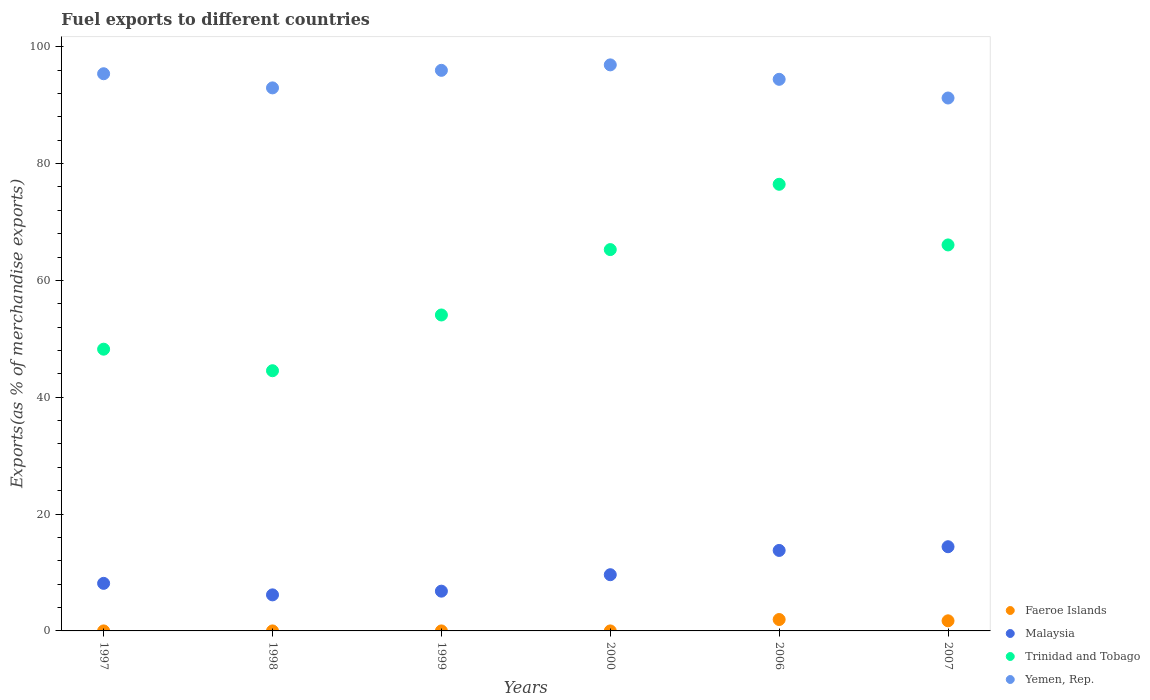What is the percentage of exports to different countries in Trinidad and Tobago in 1999?
Offer a terse response. 54.08. Across all years, what is the maximum percentage of exports to different countries in Trinidad and Tobago?
Your response must be concise. 76.46. Across all years, what is the minimum percentage of exports to different countries in Yemen, Rep.?
Provide a short and direct response. 91.23. What is the total percentage of exports to different countries in Malaysia in the graph?
Your answer should be compact. 58.93. What is the difference between the percentage of exports to different countries in Malaysia in 1997 and that in 1999?
Offer a terse response. 1.34. What is the difference between the percentage of exports to different countries in Faeroe Islands in 2006 and the percentage of exports to different countries in Yemen, Rep. in 2007?
Your response must be concise. -89.28. What is the average percentage of exports to different countries in Yemen, Rep. per year?
Offer a terse response. 94.48. In the year 1998, what is the difference between the percentage of exports to different countries in Faeroe Islands and percentage of exports to different countries in Yemen, Rep.?
Your response must be concise. -92.96. What is the ratio of the percentage of exports to different countries in Faeroe Islands in 1998 to that in 2006?
Keep it short and to the point. 0. What is the difference between the highest and the second highest percentage of exports to different countries in Yemen, Rep.?
Offer a very short reply. 0.93. What is the difference between the highest and the lowest percentage of exports to different countries in Yemen, Rep.?
Provide a short and direct response. 5.67. Is the sum of the percentage of exports to different countries in Faeroe Islands in 2000 and 2006 greater than the maximum percentage of exports to different countries in Trinidad and Tobago across all years?
Your answer should be compact. No. Does the percentage of exports to different countries in Faeroe Islands monotonically increase over the years?
Your response must be concise. No. Is the percentage of exports to different countries in Faeroe Islands strictly less than the percentage of exports to different countries in Yemen, Rep. over the years?
Your answer should be compact. Yes. How many dotlines are there?
Your response must be concise. 4. What is the difference between two consecutive major ticks on the Y-axis?
Offer a terse response. 20. Are the values on the major ticks of Y-axis written in scientific E-notation?
Keep it short and to the point. No. Does the graph contain any zero values?
Keep it short and to the point. No. Does the graph contain grids?
Provide a succinct answer. No. Where does the legend appear in the graph?
Provide a succinct answer. Bottom right. How many legend labels are there?
Your answer should be very brief. 4. What is the title of the graph?
Offer a terse response. Fuel exports to different countries. Does "Sudan" appear as one of the legend labels in the graph?
Your answer should be compact. No. What is the label or title of the Y-axis?
Keep it short and to the point. Exports(as % of merchandise exports). What is the Exports(as % of merchandise exports) in Faeroe Islands in 1997?
Ensure brevity in your answer.  0. What is the Exports(as % of merchandise exports) in Malaysia in 1997?
Give a very brief answer. 8.14. What is the Exports(as % of merchandise exports) of Trinidad and Tobago in 1997?
Provide a short and direct response. 48.23. What is the Exports(as % of merchandise exports) in Yemen, Rep. in 1997?
Offer a very short reply. 95.38. What is the Exports(as % of merchandise exports) of Faeroe Islands in 1998?
Your answer should be compact. 0. What is the Exports(as % of merchandise exports) of Malaysia in 1998?
Offer a very short reply. 6.17. What is the Exports(as % of merchandise exports) of Trinidad and Tobago in 1998?
Your answer should be very brief. 44.54. What is the Exports(as % of merchandise exports) of Yemen, Rep. in 1998?
Your answer should be very brief. 92.96. What is the Exports(as % of merchandise exports) of Faeroe Islands in 1999?
Make the answer very short. 0. What is the Exports(as % of merchandise exports) of Malaysia in 1999?
Make the answer very short. 6.81. What is the Exports(as % of merchandise exports) in Trinidad and Tobago in 1999?
Make the answer very short. 54.08. What is the Exports(as % of merchandise exports) in Yemen, Rep. in 1999?
Give a very brief answer. 95.96. What is the Exports(as % of merchandise exports) in Faeroe Islands in 2000?
Your response must be concise. 5.55871303274651e-5. What is the Exports(as % of merchandise exports) in Malaysia in 2000?
Your answer should be very brief. 9.62. What is the Exports(as % of merchandise exports) in Trinidad and Tobago in 2000?
Your answer should be very brief. 65.28. What is the Exports(as % of merchandise exports) of Yemen, Rep. in 2000?
Provide a short and direct response. 96.9. What is the Exports(as % of merchandise exports) of Faeroe Islands in 2006?
Provide a succinct answer. 1.95. What is the Exports(as % of merchandise exports) in Malaysia in 2006?
Your answer should be very brief. 13.78. What is the Exports(as % of merchandise exports) in Trinidad and Tobago in 2006?
Provide a short and direct response. 76.46. What is the Exports(as % of merchandise exports) in Yemen, Rep. in 2006?
Make the answer very short. 94.43. What is the Exports(as % of merchandise exports) of Faeroe Islands in 2007?
Give a very brief answer. 1.73. What is the Exports(as % of merchandise exports) of Malaysia in 2007?
Provide a short and direct response. 14.41. What is the Exports(as % of merchandise exports) in Trinidad and Tobago in 2007?
Give a very brief answer. 66.08. What is the Exports(as % of merchandise exports) in Yemen, Rep. in 2007?
Your answer should be compact. 91.23. Across all years, what is the maximum Exports(as % of merchandise exports) of Faeroe Islands?
Your answer should be very brief. 1.95. Across all years, what is the maximum Exports(as % of merchandise exports) in Malaysia?
Offer a terse response. 14.41. Across all years, what is the maximum Exports(as % of merchandise exports) of Trinidad and Tobago?
Your response must be concise. 76.46. Across all years, what is the maximum Exports(as % of merchandise exports) of Yemen, Rep.?
Offer a very short reply. 96.9. Across all years, what is the minimum Exports(as % of merchandise exports) in Faeroe Islands?
Give a very brief answer. 5.55871303274651e-5. Across all years, what is the minimum Exports(as % of merchandise exports) in Malaysia?
Keep it short and to the point. 6.17. Across all years, what is the minimum Exports(as % of merchandise exports) of Trinidad and Tobago?
Offer a very short reply. 44.54. Across all years, what is the minimum Exports(as % of merchandise exports) of Yemen, Rep.?
Provide a short and direct response. 91.23. What is the total Exports(as % of merchandise exports) of Faeroe Islands in the graph?
Make the answer very short. 3.68. What is the total Exports(as % of merchandise exports) of Malaysia in the graph?
Your answer should be compact. 58.93. What is the total Exports(as % of merchandise exports) of Trinidad and Tobago in the graph?
Your response must be concise. 354.66. What is the total Exports(as % of merchandise exports) in Yemen, Rep. in the graph?
Your answer should be very brief. 566.85. What is the difference between the Exports(as % of merchandise exports) of Faeroe Islands in 1997 and that in 1998?
Your answer should be compact. 0. What is the difference between the Exports(as % of merchandise exports) in Malaysia in 1997 and that in 1998?
Offer a terse response. 1.97. What is the difference between the Exports(as % of merchandise exports) in Trinidad and Tobago in 1997 and that in 1998?
Give a very brief answer. 3.69. What is the difference between the Exports(as % of merchandise exports) in Yemen, Rep. in 1997 and that in 1998?
Your answer should be very brief. 2.42. What is the difference between the Exports(as % of merchandise exports) in Faeroe Islands in 1997 and that in 1999?
Offer a very short reply. 0. What is the difference between the Exports(as % of merchandise exports) of Malaysia in 1997 and that in 1999?
Provide a short and direct response. 1.34. What is the difference between the Exports(as % of merchandise exports) of Trinidad and Tobago in 1997 and that in 1999?
Offer a terse response. -5.86. What is the difference between the Exports(as % of merchandise exports) in Yemen, Rep. in 1997 and that in 1999?
Keep it short and to the point. -0.58. What is the difference between the Exports(as % of merchandise exports) of Malaysia in 1997 and that in 2000?
Make the answer very short. -1.48. What is the difference between the Exports(as % of merchandise exports) of Trinidad and Tobago in 1997 and that in 2000?
Your answer should be compact. -17.05. What is the difference between the Exports(as % of merchandise exports) in Yemen, Rep. in 1997 and that in 2000?
Give a very brief answer. -1.52. What is the difference between the Exports(as % of merchandise exports) of Faeroe Islands in 1997 and that in 2006?
Ensure brevity in your answer.  -1.95. What is the difference between the Exports(as % of merchandise exports) of Malaysia in 1997 and that in 2006?
Make the answer very short. -5.64. What is the difference between the Exports(as % of merchandise exports) of Trinidad and Tobago in 1997 and that in 2006?
Provide a short and direct response. -28.23. What is the difference between the Exports(as % of merchandise exports) of Yemen, Rep. in 1997 and that in 2006?
Keep it short and to the point. 0.95. What is the difference between the Exports(as % of merchandise exports) of Faeroe Islands in 1997 and that in 2007?
Ensure brevity in your answer.  -1.73. What is the difference between the Exports(as % of merchandise exports) of Malaysia in 1997 and that in 2007?
Your answer should be compact. -6.27. What is the difference between the Exports(as % of merchandise exports) of Trinidad and Tobago in 1997 and that in 2007?
Your answer should be compact. -17.85. What is the difference between the Exports(as % of merchandise exports) of Yemen, Rep. in 1997 and that in 2007?
Your response must be concise. 4.15. What is the difference between the Exports(as % of merchandise exports) in Faeroe Islands in 1998 and that in 1999?
Give a very brief answer. -0. What is the difference between the Exports(as % of merchandise exports) in Malaysia in 1998 and that in 1999?
Your answer should be compact. -0.63. What is the difference between the Exports(as % of merchandise exports) in Trinidad and Tobago in 1998 and that in 1999?
Provide a succinct answer. -9.54. What is the difference between the Exports(as % of merchandise exports) of Yemen, Rep. in 1998 and that in 1999?
Your answer should be compact. -3. What is the difference between the Exports(as % of merchandise exports) in Faeroe Islands in 1998 and that in 2000?
Provide a short and direct response. 0. What is the difference between the Exports(as % of merchandise exports) in Malaysia in 1998 and that in 2000?
Your answer should be very brief. -3.45. What is the difference between the Exports(as % of merchandise exports) in Trinidad and Tobago in 1998 and that in 2000?
Make the answer very short. -20.74. What is the difference between the Exports(as % of merchandise exports) of Yemen, Rep. in 1998 and that in 2000?
Your response must be concise. -3.94. What is the difference between the Exports(as % of merchandise exports) of Faeroe Islands in 1998 and that in 2006?
Ensure brevity in your answer.  -1.95. What is the difference between the Exports(as % of merchandise exports) in Malaysia in 1998 and that in 2006?
Offer a very short reply. -7.61. What is the difference between the Exports(as % of merchandise exports) of Trinidad and Tobago in 1998 and that in 2006?
Keep it short and to the point. -31.91. What is the difference between the Exports(as % of merchandise exports) in Yemen, Rep. in 1998 and that in 2006?
Your answer should be compact. -1.47. What is the difference between the Exports(as % of merchandise exports) in Faeroe Islands in 1998 and that in 2007?
Make the answer very short. -1.73. What is the difference between the Exports(as % of merchandise exports) of Malaysia in 1998 and that in 2007?
Provide a short and direct response. -8.24. What is the difference between the Exports(as % of merchandise exports) of Trinidad and Tobago in 1998 and that in 2007?
Your response must be concise. -21.53. What is the difference between the Exports(as % of merchandise exports) of Yemen, Rep. in 1998 and that in 2007?
Offer a terse response. 1.73. What is the difference between the Exports(as % of merchandise exports) in Faeroe Islands in 1999 and that in 2000?
Your answer should be compact. 0. What is the difference between the Exports(as % of merchandise exports) in Malaysia in 1999 and that in 2000?
Offer a very short reply. -2.82. What is the difference between the Exports(as % of merchandise exports) of Trinidad and Tobago in 1999 and that in 2000?
Make the answer very short. -11.19. What is the difference between the Exports(as % of merchandise exports) in Yemen, Rep. in 1999 and that in 2000?
Make the answer very short. -0.93. What is the difference between the Exports(as % of merchandise exports) in Faeroe Islands in 1999 and that in 2006?
Make the answer very short. -1.95. What is the difference between the Exports(as % of merchandise exports) in Malaysia in 1999 and that in 2006?
Ensure brevity in your answer.  -6.97. What is the difference between the Exports(as % of merchandise exports) in Trinidad and Tobago in 1999 and that in 2006?
Give a very brief answer. -22.37. What is the difference between the Exports(as % of merchandise exports) of Yemen, Rep. in 1999 and that in 2006?
Keep it short and to the point. 1.54. What is the difference between the Exports(as % of merchandise exports) in Faeroe Islands in 1999 and that in 2007?
Offer a terse response. -1.73. What is the difference between the Exports(as % of merchandise exports) of Malaysia in 1999 and that in 2007?
Make the answer very short. -7.61. What is the difference between the Exports(as % of merchandise exports) in Trinidad and Tobago in 1999 and that in 2007?
Offer a terse response. -11.99. What is the difference between the Exports(as % of merchandise exports) in Yemen, Rep. in 1999 and that in 2007?
Provide a short and direct response. 4.74. What is the difference between the Exports(as % of merchandise exports) of Faeroe Islands in 2000 and that in 2006?
Your answer should be compact. -1.95. What is the difference between the Exports(as % of merchandise exports) of Malaysia in 2000 and that in 2006?
Make the answer very short. -4.15. What is the difference between the Exports(as % of merchandise exports) in Trinidad and Tobago in 2000 and that in 2006?
Make the answer very short. -11.18. What is the difference between the Exports(as % of merchandise exports) of Yemen, Rep. in 2000 and that in 2006?
Ensure brevity in your answer.  2.47. What is the difference between the Exports(as % of merchandise exports) of Faeroe Islands in 2000 and that in 2007?
Your answer should be compact. -1.73. What is the difference between the Exports(as % of merchandise exports) in Malaysia in 2000 and that in 2007?
Ensure brevity in your answer.  -4.79. What is the difference between the Exports(as % of merchandise exports) of Trinidad and Tobago in 2000 and that in 2007?
Ensure brevity in your answer.  -0.8. What is the difference between the Exports(as % of merchandise exports) in Yemen, Rep. in 2000 and that in 2007?
Provide a succinct answer. 5.67. What is the difference between the Exports(as % of merchandise exports) in Faeroe Islands in 2006 and that in 2007?
Provide a succinct answer. 0.22. What is the difference between the Exports(as % of merchandise exports) in Malaysia in 2006 and that in 2007?
Offer a terse response. -0.63. What is the difference between the Exports(as % of merchandise exports) of Trinidad and Tobago in 2006 and that in 2007?
Provide a succinct answer. 10.38. What is the difference between the Exports(as % of merchandise exports) in Yemen, Rep. in 2006 and that in 2007?
Give a very brief answer. 3.2. What is the difference between the Exports(as % of merchandise exports) in Faeroe Islands in 1997 and the Exports(as % of merchandise exports) in Malaysia in 1998?
Your response must be concise. -6.17. What is the difference between the Exports(as % of merchandise exports) in Faeroe Islands in 1997 and the Exports(as % of merchandise exports) in Trinidad and Tobago in 1998?
Ensure brevity in your answer.  -44.54. What is the difference between the Exports(as % of merchandise exports) in Faeroe Islands in 1997 and the Exports(as % of merchandise exports) in Yemen, Rep. in 1998?
Give a very brief answer. -92.96. What is the difference between the Exports(as % of merchandise exports) in Malaysia in 1997 and the Exports(as % of merchandise exports) in Trinidad and Tobago in 1998?
Offer a terse response. -36.4. What is the difference between the Exports(as % of merchandise exports) in Malaysia in 1997 and the Exports(as % of merchandise exports) in Yemen, Rep. in 1998?
Offer a terse response. -84.82. What is the difference between the Exports(as % of merchandise exports) in Trinidad and Tobago in 1997 and the Exports(as % of merchandise exports) in Yemen, Rep. in 1998?
Your answer should be compact. -44.73. What is the difference between the Exports(as % of merchandise exports) of Faeroe Islands in 1997 and the Exports(as % of merchandise exports) of Malaysia in 1999?
Give a very brief answer. -6.81. What is the difference between the Exports(as % of merchandise exports) of Faeroe Islands in 1997 and the Exports(as % of merchandise exports) of Trinidad and Tobago in 1999?
Keep it short and to the point. -54.08. What is the difference between the Exports(as % of merchandise exports) of Faeroe Islands in 1997 and the Exports(as % of merchandise exports) of Yemen, Rep. in 1999?
Provide a succinct answer. -95.96. What is the difference between the Exports(as % of merchandise exports) of Malaysia in 1997 and the Exports(as % of merchandise exports) of Trinidad and Tobago in 1999?
Your answer should be compact. -45.94. What is the difference between the Exports(as % of merchandise exports) in Malaysia in 1997 and the Exports(as % of merchandise exports) in Yemen, Rep. in 1999?
Keep it short and to the point. -87.82. What is the difference between the Exports(as % of merchandise exports) of Trinidad and Tobago in 1997 and the Exports(as % of merchandise exports) of Yemen, Rep. in 1999?
Offer a very short reply. -47.74. What is the difference between the Exports(as % of merchandise exports) of Faeroe Islands in 1997 and the Exports(as % of merchandise exports) of Malaysia in 2000?
Keep it short and to the point. -9.62. What is the difference between the Exports(as % of merchandise exports) of Faeroe Islands in 1997 and the Exports(as % of merchandise exports) of Trinidad and Tobago in 2000?
Make the answer very short. -65.28. What is the difference between the Exports(as % of merchandise exports) of Faeroe Islands in 1997 and the Exports(as % of merchandise exports) of Yemen, Rep. in 2000?
Offer a terse response. -96.9. What is the difference between the Exports(as % of merchandise exports) of Malaysia in 1997 and the Exports(as % of merchandise exports) of Trinidad and Tobago in 2000?
Give a very brief answer. -57.14. What is the difference between the Exports(as % of merchandise exports) of Malaysia in 1997 and the Exports(as % of merchandise exports) of Yemen, Rep. in 2000?
Offer a terse response. -88.76. What is the difference between the Exports(as % of merchandise exports) in Trinidad and Tobago in 1997 and the Exports(as % of merchandise exports) in Yemen, Rep. in 2000?
Your response must be concise. -48.67. What is the difference between the Exports(as % of merchandise exports) of Faeroe Islands in 1997 and the Exports(as % of merchandise exports) of Malaysia in 2006?
Offer a terse response. -13.78. What is the difference between the Exports(as % of merchandise exports) in Faeroe Islands in 1997 and the Exports(as % of merchandise exports) in Trinidad and Tobago in 2006?
Your answer should be very brief. -76.45. What is the difference between the Exports(as % of merchandise exports) in Faeroe Islands in 1997 and the Exports(as % of merchandise exports) in Yemen, Rep. in 2006?
Your answer should be compact. -94.42. What is the difference between the Exports(as % of merchandise exports) of Malaysia in 1997 and the Exports(as % of merchandise exports) of Trinidad and Tobago in 2006?
Keep it short and to the point. -68.31. What is the difference between the Exports(as % of merchandise exports) of Malaysia in 1997 and the Exports(as % of merchandise exports) of Yemen, Rep. in 2006?
Offer a terse response. -86.28. What is the difference between the Exports(as % of merchandise exports) in Trinidad and Tobago in 1997 and the Exports(as % of merchandise exports) in Yemen, Rep. in 2006?
Keep it short and to the point. -46.2. What is the difference between the Exports(as % of merchandise exports) of Faeroe Islands in 1997 and the Exports(as % of merchandise exports) of Malaysia in 2007?
Your response must be concise. -14.41. What is the difference between the Exports(as % of merchandise exports) of Faeroe Islands in 1997 and the Exports(as % of merchandise exports) of Trinidad and Tobago in 2007?
Make the answer very short. -66.07. What is the difference between the Exports(as % of merchandise exports) in Faeroe Islands in 1997 and the Exports(as % of merchandise exports) in Yemen, Rep. in 2007?
Make the answer very short. -91.23. What is the difference between the Exports(as % of merchandise exports) of Malaysia in 1997 and the Exports(as % of merchandise exports) of Trinidad and Tobago in 2007?
Your answer should be compact. -57.93. What is the difference between the Exports(as % of merchandise exports) of Malaysia in 1997 and the Exports(as % of merchandise exports) of Yemen, Rep. in 2007?
Your answer should be compact. -83.09. What is the difference between the Exports(as % of merchandise exports) in Trinidad and Tobago in 1997 and the Exports(as % of merchandise exports) in Yemen, Rep. in 2007?
Give a very brief answer. -43. What is the difference between the Exports(as % of merchandise exports) of Faeroe Islands in 1998 and the Exports(as % of merchandise exports) of Malaysia in 1999?
Provide a short and direct response. -6.81. What is the difference between the Exports(as % of merchandise exports) of Faeroe Islands in 1998 and the Exports(as % of merchandise exports) of Trinidad and Tobago in 1999?
Offer a terse response. -54.08. What is the difference between the Exports(as % of merchandise exports) in Faeroe Islands in 1998 and the Exports(as % of merchandise exports) in Yemen, Rep. in 1999?
Ensure brevity in your answer.  -95.96. What is the difference between the Exports(as % of merchandise exports) in Malaysia in 1998 and the Exports(as % of merchandise exports) in Trinidad and Tobago in 1999?
Your answer should be very brief. -47.91. What is the difference between the Exports(as % of merchandise exports) of Malaysia in 1998 and the Exports(as % of merchandise exports) of Yemen, Rep. in 1999?
Offer a very short reply. -89.79. What is the difference between the Exports(as % of merchandise exports) of Trinidad and Tobago in 1998 and the Exports(as % of merchandise exports) of Yemen, Rep. in 1999?
Keep it short and to the point. -51.42. What is the difference between the Exports(as % of merchandise exports) in Faeroe Islands in 1998 and the Exports(as % of merchandise exports) in Malaysia in 2000?
Your answer should be very brief. -9.62. What is the difference between the Exports(as % of merchandise exports) of Faeroe Islands in 1998 and the Exports(as % of merchandise exports) of Trinidad and Tobago in 2000?
Offer a terse response. -65.28. What is the difference between the Exports(as % of merchandise exports) in Faeroe Islands in 1998 and the Exports(as % of merchandise exports) in Yemen, Rep. in 2000?
Your answer should be compact. -96.9. What is the difference between the Exports(as % of merchandise exports) in Malaysia in 1998 and the Exports(as % of merchandise exports) in Trinidad and Tobago in 2000?
Your response must be concise. -59.11. What is the difference between the Exports(as % of merchandise exports) of Malaysia in 1998 and the Exports(as % of merchandise exports) of Yemen, Rep. in 2000?
Provide a succinct answer. -90.73. What is the difference between the Exports(as % of merchandise exports) of Trinidad and Tobago in 1998 and the Exports(as % of merchandise exports) of Yemen, Rep. in 2000?
Offer a very short reply. -52.36. What is the difference between the Exports(as % of merchandise exports) of Faeroe Islands in 1998 and the Exports(as % of merchandise exports) of Malaysia in 2006?
Ensure brevity in your answer.  -13.78. What is the difference between the Exports(as % of merchandise exports) in Faeroe Islands in 1998 and the Exports(as % of merchandise exports) in Trinidad and Tobago in 2006?
Your answer should be compact. -76.46. What is the difference between the Exports(as % of merchandise exports) of Faeroe Islands in 1998 and the Exports(as % of merchandise exports) of Yemen, Rep. in 2006?
Give a very brief answer. -94.42. What is the difference between the Exports(as % of merchandise exports) of Malaysia in 1998 and the Exports(as % of merchandise exports) of Trinidad and Tobago in 2006?
Your answer should be compact. -70.28. What is the difference between the Exports(as % of merchandise exports) of Malaysia in 1998 and the Exports(as % of merchandise exports) of Yemen, Rep. in 2006?
Offer a very short reply. -88.25. What is the difference between the Exports(as % of merchandise exports) of Trinidad and Tobago in 1998 and the Exports(as % of merchandise exports) of Yemen, Rep. in 2006?
Ensure brevity in your answer.  -49.88. What is the difference between the Exports(as % of merchandise exports) in Faeroe Islands in 1998 and the Exports(as % of merchandise exports) in Malaysia in 2007?
Your response must be concise. -14.41. What is the difference between the Exports(as % of merchandise exports) of Faeroe Islands in 1998 and the Exports(as % of merchandise exports) of Trinidad and Tobago in 2007?
Your answer should be compact. -66.08. What is the difference between the Exports(as % of merchandise exports) of Faeroe Islands in 1998 and the Exports(as % of merchandise exports) of Yemen, Rep. in 2007?
Your answer should be compact. -91.23. What is the difference between the Exports(as % of merchandise exports) of Malaysia in 1998 and the Exports(as % of merchandise exports) of Trinidad and Tobago in 2007?
Your answer should be compact. -59.9. What is the difference between the Exports(as % of merchandise exports) in Malaysia in 1998 and the Exports(as % of merchandise exports) in Yemen, Rep. in 2007?
Provide a succinct answer. -85.05. What is the difference between the Exports(as % of merchandise exports) in Trinidad and Tobago in 1998 and the Exports(as % of merchandise exports) in Yemen, Rep. in 2007?
Offer a terse response. -46.69. What is the difference between the Exports(as % of merchandise exports) of Faeroe Islands in 1999 and the Exports(as % of merchandise exports) of Malaysia in 2000?
Your response must be concise. -9.62. What is the difference between the Exports(as % of merchandise exports) in Faeroe Islands in 1999 and the Exports(as % of merchandise exports) in Trinidad and Tobago in 2000?
Your answer should be very brief. -65.28. What is the difference between the Exports(as % of merchandise exports) of Faeroe Islands in 1999 and the Exports(as % of merchandise exports) of Yemen, Rep. in 2000?
Keep it short and to the point. -96.9. What is the difference between the Exports(as % of merchandise exports) of Malaysia in 1999 and the Exports(as % of merchandise exports) of Trinidad and Tobago in 2000?
Provide a succinct answer. -58.47. What is the difference between the Exports(as % of merchandise exports) of Malaysia in 1999 and the Exports(as % of merchandise exports) of Yemen, Rep. in 2000?
Ensure brevity in your answer.  -90.09. What is the difference between the Exports(as % of merchandise exports) of Trinidad and Tobago in 1999 and the Exports(as % of merchandise exports) of Yemen, Rep. in 2000?
Your answer should be very brief. -42.81. What is the difference between the Exports(as % of merchandise exports) in Faeroe Islands in 1999 and the Exports(as % of merchandise exports) in Malaysia in 2006?
Provide a succinct answer. -13.78. What is the difference between the Exports(as % of merchandise exports) of Faeroe Islands in 1999 and the Exports(as % of merchandise exports) of Trinidad and Tobago in 2006?
Ensure brevity in your answer.  -76.45. What is the difference between the Exports(as % of merchandise exports) in Faeroe Islands in 1999 and the Exports(as % of merchandise exports) in Yemen, Rep. in 2006?
Provide a short and direct response. -94.42. What is the difference between the Exports(as % of merchandise exports) of Malaysia in 1999 and the Exports(as % of merchandise exports) of Trinidad and Tobago in 2006?
Your answer should be very brief. -69.65. What is the difference between the Exports(as % of merchandise exports) of Malaysia in 1999 and the Exports(as % of merchandise exports) of Yemen, Rep. in 2006?
Your answer should be compact. -87.62. What is the difference between the Exports(as % of merchandise exports) in Trinidad and Tobago in 1999 and the Exports(as % of merchandise exports) in Yemen, Rep. in 2006?
Make the answer very short. -40.34. What is the difference between the Exports(as % of merchandise exports) in Faeroe Islands in 1999 and the Exports(as % of merchandise exports) in Malaysia in 2007?
Ensure brevity in your answer.  -14.41. What is the difference between the Exports(as % of merchandise exports) in Faeroe Islands in 1999 and the Exports(as % of merchandise exports) in Trinidad and Tobago in 2007?
Provide a short and direct response. -66.08. What is the difference between the Exports(as % of merchandise exports) in Faeroe Islands in 1999 and the Exports(as % of merchandise exports) in Yemen, Rep. in 2007?
Make the answer very short. -91.23. What is the difference between the Exports(as % of merchandise exports) of Malaysia in 1999 and the Exports(as % of merchandise exports) of Trinidad and Tobago in 2007?
Make the answer very short. -59.27. What is the difference between the Exports(as % of merchandise exports) in Malaysia in 1999 and the Exports(as % of merchandise exports) in Yemen, Rep. in 2007?
Keep it short and to the point. -84.42. What is the difference between the Exports(as % of merchandise exports) of Trinidad and Tobago in 1999 and the Exports(as % of merchandise exports) of Yemen, Rep. in 2007?
Give a very brief answer. -37.14. What is the difference between the Exports(as % of merchandise exports) in Faeroe Islands in 2000 and the Exports(as % of merchandise exports) in Malaysia in 2006?
Offer a terse response. -13.78. What is the difference between the Exports(as % of merchandise exports) in Faeroe Islands in 2000 and the Exports(as % of merchandise exports) in Trinidad and Tobago in 2006?
Keep it short and to the point. -76.46. What is the difference between the Exports(as % of merchandise exports) in Faeroe Islands in 2000 and the Exports(as % of merchandise exports) in Yemen, Rep. in 2006?
Your answer should be compact. -94.43. What is the difference between the Exports(as % of merchandise exports) of Malaysia in 2000 and the Exports(as % of merchandise exports) of Trinidad and Tobago in 2006?
Provide a short and direct response. -66.83. What is the difference between the Exports(as % of merchandise exports) in Malaysia in 2000 and the Exports(as % of merchandise exports) in Yemen, Rep. in 2006?
Provide a short and direct response. -84.8. What is the difference between the Exports(as % of merchandise exports) in Trinidad and Tobago in 2000 and the Exports(as % of merchandise exports) in Yemen, Rep. in 2006?
Offer a very short reply. -29.15. What is the difference between the Exports(as % of merchandise exports) in Faeroe Islands in 2000 and the Exports(as % of merchandise exports) in Malaysia in 2007?
Your answer should be compact. -14.41. What is the difference between the Exports(as % of merchandise exports) in Faeroe Islands in 2000 and the Exports(as % of merchandise exports) in Trinidad and Tobago in 2007?
Offer a terse response. -66.08. What is the difference between the Exports(as % of merchandise exports) of Faeroe Islands in 2000 and the Exports(as % of merchandise exports) of Yemen, Rep. in 2007?
Ensure brevity in your answer.  -91.23. What is the difference between the Exports(as % of merchandise exports) of Malaysia in 2000 and the Exports(as % of merchandise exports) of Trinidad and Tobago in 2007?
Give a very brief answer. -56.45. What is the difference between the Exports(as % of merchandise exports) in Malaysia in 2000 and the Exports(as % of merchandise exports) in Yemen, Rep. in 2007?
Make the answer very short. -81.6. What is the difference between the Exports(as % of merchandise exports) of Trinidad and Tobago in 2000 and the Exports(as % of merchandise exports) of Yemen, Rep. in 2007?
Your response must be concise. -25.95. What is the difference between the Exports(as % of merchandise exports) in Faeroe Islands in 2006 and the Exports(as % of merchandise exports) in Malaysia in 2007?
Make the answer very short. -12.46. What is the difference between the Exports(as % of merchandise exports) in Faeroe Islands in 2006 and the Exports(as % of merchandise exports) in Trinidad and Tobago in 2007?
Keep it short and to the point. -64.12. What is the difference between the Exports(as % of merchandise exports) of Faeroe Islands in 2006 and the Exports(as % of merchandise exports) of Yemen, Rep. in 2007?
Keep it short and to the point. -89.28. What is the difference between the Exports(as % of merchandise exports) of Malaysia in 2006 and the Exports(as % of merchandise exports) of Trinidad and Tobago in 2007?
Ensure brevity in your answer.  -52.3. What is the difference between the Exports(as % of merchandise exports) of Malaysia in 2006 and the Exports(as % of merchandise exports) of Yemen, Rep. in 2007?
Offer a terse response. -77.45. What is the difference between the Exports(as % of merchandise exports) in Trinidad and Tobago in 2006 and the Exports(as % of merchandise exports) in Yemen, Rep. in 2007?
Make the answer very short. -14.77. What is the average Exports(as % of merchandise exports) in Faeroe Islands per year?
Offer a terse response. 0.61. What is the average Exports(as % of merchandise exports) of Malaysia per year?
Offer a terse response. 9.82. What is the average Exports(as % of merchandise exports) of Trinidad and Tobago per year?
Your response must be concise. 59.11. What is the average Exports(as % of merchandise exports) of Yemen, Rep. per year?
Offer a terse response. 94.48. In the year 1997, what is the difference between the Exports(as % of merchandise exports) in Faeroe Islands and Exports(as % of merchandise exports) in Malaysia?
Ensure brevity in your answer.  -8.14. In the year 1997, what is the difference between the Exports(as % of merchandise exports) in Faeroe Islands and Exports(as % of merchandise exports) in Trinidad and Tobago?
Keep it short and to the point. -48.23. In the year 1997, what is the difference between the Exports(as % of merchandise exports) of Faeroe Islands and Exports(as % of merchandise exports) of Yemen, Rep.?
Your answer should be very brief. -95.38. In the year 1997, what is the difference between the Exports(as % of merchandise exports) of Malaysia and Exports(as % of merchandise exports) of Trinidad and Tobago?
Provide a succinct answer. -40.09. In the year 1997, what is the difference between the Exports(as % of merchandise exports) in Malaysia and Exports(as % of merchandise exports) in Yemen, Rep.?
Your answer should be very brief. -87.24. In the year 1997, what is the difference between the Exports(as % of merchandise exports) of Trinidad and Tobago and Exports(as % of merchandise exports) of Yemen, Rep.?
Your answer should be compact. -47.15. In the year 1998, what is the difference between the Exports(as % of merchandise exports) of Faeroe Islands and Exports(as % of merchandise exports) of Malaysia?
Provide a short and direct response. -6.17. In the year 1998, what is the difference between the Exports(as % of merchandise exports) in Faeroe Islands and Exports(as % of merchandise exports) in Trinidad and Tobago?
Provide a short and direct response. -44.54. In the year 1998, what is the difference between the Exports(as % of merchandise exports) of Faeroe Islands and Exports(as % of merchandise exports) of Yemen, Rep.?
Your answer should be compact. -92.96. In the year 1998, what is the difference between the Exports(as % of merchandise exports) of Malaysia and Exports(as % of merchandise exports) of Trinidad and Tobago?
Provide a short and direct response. -38.37. In the year 1998, what is the difference between the Exports(as % of merchandise exports) in Malaysia and Exports(as % of merchandise exports) in Yemen, Rep.?
Your answer should be compact. -86.79. In the year 1998, what is the difference between the Exports(as % of merchandise exports) of Trinidad and Tobago and Exports(as % of merchandise exports) of Yemen, Rep.?
Your answer should be compact. -48.42. In the year 1999, what is the difference between the Exports(as % of merchandise exports) of Faeroe Islands and Exports(as % of merchandise exports) of Malaysia?
Your answer should be compact. -6.81. In the year 1999, what is the difference between the Exports(as % of merchandise exports) of Faeroe Islands and Exports(as % of merchandise exports) of Trinidad and Tobago?
Offer a terse response. -54.08. In the year 1999, what is the difference between the Exports(as % of merchandise exports) of Faeroe Islands and Exports(as % of merchandise exports) of Yemen, Rep.?
Offer a very short reply. -95.96. In the year 1999, what is the difference between the Exports(as % of merchandise exports) in Malaysia and Exports(as % of merchandise exports) in Trinidad and Tobago?
Provide a succinct answer. -47.28. In the year 1999, what is the difference between the Exports(as % of merchandise exports) in Malaysia and Exports(as % of merchandise exports) in Yemen, Rep.?
Your response must be concise. -89.16. In the year 1999, what is the difference between the Exports(as % of merchandise exports) of Trinidad and Tobago and Exports(as % of merchandise exports) of Yemen, Rep.?
Your answer should be very brief. -41.88. In the year 2000, what is the difference between the Exports(as % of merchandise exports) of Faeroe Islands and Exports(as % of merchandise exports) of Malaysia?
Your response must be concise. -9.62. In the year 2000, what is the difference between the Exports(as % of merchandise exports) in Faeroe Islands and Exports(as % of merchandise exports) in Trinidad and Tobago?
Ensure brevity in your answer.  -65.28. In the year 2000, what is the difference between the Exports(as % of merchandise exports) of Faeroe Islands and Exports(as % of merchandise exports) of Yemen, Rep.?
Keep it short and to the point. -96.9. In the year 2000, what is the difference between the Exports(as % of merchandise exports) in Malaysia and Exports(as % of merchandise exports) in Trinidad and Tobago?
Provide a short and direct response. -55.65. In the year 2000, what is the difference between the Exports(as % of merchandise exports) of Malaysia and Exports(as % of merchandise exports) of Yemen, Rep.?
Make the answer very short. -87.27. In the year 2000, what is the difference between the Exports(as % of merchandise exports) of Trinidad and Tobago and Exports(as % of merchandise exports) of Yemen, Rep.?
Offer a terse response. -31.62. In the year 2006, what is the difference between the Exports(as % of merchandise exports) of Faeroe Islands and Exports(as % of merchandise exports) of Malaysia?
Keep it short and to the point. -11.83. In the year 2006, what is the difference between the Exports(as % of merchandise exports) in Faeroe Islands and Exports(as % of merchandise exports) in Trinidad and Tobago?
Your answer should be compact. -74.5. In the year 2006, what is the difference between the Exports(as % of merchandise exports) in Faeroe Islands and Exports(as % of merchandise exports) in Yemen, Rep.?
Keep it short and to the point. -92.47. In the year 2006, what is the difference between the Exports(as % of merchandise exports) in Malaysia and Exports(as % of merchandise exports) in Trinidad and Tobago?
Provide a succinct answer. -62.68. In the year 2006, what is the difference between the Exports(as % of merchandise exports) of Malaysia and Exports(as % of merchandise exports) of Yemen, Rep.?
Keep it short and to the point. -80.65. In the year 2006, what is the difference between the Exports(as % of merchandise exports) of Trinidad and Tobago and Exports(as % of merchandise exports) of Yemen, Rep.?
Offer a terse response. -17.97. In the year 2007, what is the difference between the Exports(as % of merchandise exports) in Faeroe Islands and Exports(as % of merchandise exports) in Malaysia?
Keep it short and to the point. -12.68. In the year 2007, what is the difference between the Exports(as % of merchandise exports) of Faeroe Islands and Exports(as % of merchandise exports) of Trinidad and Tobago?
Your answer should be very brief. -64.35. In the year 2007, what is the difference between the Exports(as % of merchandise exports) in Faeroe Islands and Exports(as % of merchandise exports) in Yemen, Rep.?
Provide a succinct answer. -89.5. In the year 2007, what is the difference between the Exports(as % of merchandise exports) in Malaysia and Exports(as % of merchandise exports) in Trinidad and Tobago?
Provide a short and direct response. -51.66. In the year 2007, what is the difference between the Exports(as % of merchandise exports) of Malaysia and Exports(as % of merchandise exports) of Yemen, Rep.?
Ensure brevity in your answer.  -76.81. In the year 2007, what is the difference between the Exports(as % of merchandise exports) of Trinidad and Tobago and Exports(as % of merchandise exports) of Yemen, Rep.?
Provide a succinct answer. -25.15. What is the ratio of the Exports(as % of merchandise exports) in Faeroe Islands in 1997 to that in 1998?
Offer a very short reply. 4.4. What is the ratio of the Exports(as % of merchandise exports) in Malaysia in 1997 to that in 1998?
Make the answer very short. 1.32. What is the ratio of the Exports(as % of merchandise exports) of Trinidad and Tobago in 1997 to that in 1998?
Your answer should be compact. 1.08. What is the ratio of the Exports(as % of merchandise exports) in Yemen, Rep. in 1997 to that in 1998?
Make the answer very short. 1.03. What is the ratio of the Exports(as % of merchandise exports) in Faeroe Islands in 1997 to that in 1999?
Provide a short and direct response. 1.22. What is the ratio of the Exports(as % of merchandise exports) of Malaysia in 1997 to that in 1999?
Make the answer very short. 1.2. What is the ratio of the Exports(as % of merchandise exports) in Trinidad and Tobago in 1997 to that in 1999?
Make the answer very short. 0.89. What is the ratio of the Exports(as % of merchandise exports) in Faeroe Islands in 1997 to that in 2000?
Give a very brief answer. 18.32. What is the ratio of the Exports(as % of merchandise exports) of Malaysia in 1997 to that in 2000?
Your answer should be very brief. 0.85. What is the ratio of the Exports(as % of merchandise exports) in Trinidad and Tobago in 1997 to that in 2000?
Your answer should be compact. 0.74. What is the ratio of the Exports(as % of merchandise exports) of Yemen, Rep. in 1997 to that in 2000?
Offer a terse response. 0.98. What is the ratio of the Exports(as % of merchandise exports) of Faeroe Islands in 1997 to that in 2006?
Offer a very short reply. 0. What is the ratio of the Exports(as % of merchandise exports) of Malaysia in 1997 to that in 2006?
Give a very brief answer. 0.59. What is the ratio of the Exports(as % of merchandise exports) in Trinidad and Tobago in 1997 to that in 2006?
Give a very brief answer. 0.63. What is the ratio of the Exports(as % of merchandise exports) in Faeroe Islands in 1997 to that in 2007?
Provide a succinct answer. 0. What is the ratio of the Exports(as % of merchandise exports) in Malaysia in 1997 to that in 2007?
Your answer should be very brief. 0.56. What is the ratio of the Exports(as % of merchandise exports) of Trinidad and Tobago in 1997 to that in 2007?
Provide a succinct answer. 0.73. What is the ratio of the Exports(as % of merchandise exports) of Yemen, Rep. in 1997 to that in 2007?
Your answer should be very brief. 1.05. What is the ratio of the Exports(as % of merchandise exports) of Faeroe Islands in 1998 to that in 1999?
Your response must be concise. 0.28. What is the ratio of the Exports(as % of merchandise exports) in Malaysia in 1998 to that in 1999?
Offer a very short reply. 0.91. What is the ratio of the Exports(as % of merchandise exports) in Trinidad and Tobago in 1998 to that in 1999?
Offer a very short reply. 0.82. What is the ratio of the Exports(as % of merchandise exports) in Yemen, Rep. in 1998 to that in 1999?
Offer a very short reply. 0.97. What is the ratio of the Exports(as % of merchandise exports) of Faeroe Islands in 1998 to that in 2000?
Your answer should be compact. 4.16. What is the ratio of the Exports(as % of merchandise exports) of Malaysia in 1998 to that in 2000?
Provide a short and direct response. 0.64. What is the ratio of the Exports(as % of merchandise exports) in Trinidad and Tobago in 1998 to that in 2000?
Make the answer very short. 0.68. What is the ratio of the Exports(as % of merchandise exports) of Yemen, Rep. in 1998 to that in 2000?
Your response must be concise. 0.96. What is the ratio of the Exports(as % of merchandise exports) in Malaysia in 1998 to that in 2006?
Give a very brief answer. 0.45. What is the ratio of the Exports(as % of merchandise exports) in Trinidad and Tobago in 1998 to that in 2006?
Your response must be concise. 0.58. What is the ratio of the Exports(as % of merchandise exports) of Yemen, Rep. in 1998 to that in 2006?
Provide a succinct answer. 0.98. What is the ratio of the Exports(as % of merchandise exports) in Malaysia in 1998 to that in 2007?
Ensure brevity in your answer.  0.43. What is the ratio of the Exports(as % of merchandise exports) in Trinidad and Tobago in 1998 to that in 2007?
Your response must be concise. 0.67. What is the ratio of the Exports(as % of merchandise exports) in Faeroe Islands in 1999 to that in 2000?
Your answer should be very brief. 15.06. What is the ratio of the Exports(as % of merchandise exports) in Malaysia in 1999 to that in 2000?
Provide a succinct answer. 0.71. What is the ratio of the Exports(as % of merchandise exports) in Trinidad and Tobago in 1999 to that in 2000?
Make the answer very short. 0.83. What is the ratio of the Exports(as % of merchandise exports) in Yemen, Rep. in 1999 to that in 2000?
Provide a succinct answer. 0.99. What is the ratio of the Exports(as % of merchandise exports) of Malaysia in 1999 to that in 2006?
Give a very brief answer. 0.49. What is the ratio of the Exports(as % of merchandise exports) in Trinidad and Tobago in 1999 to that in 2006?
Provide a succinct answer. 0.71. What is the ratio of the Exports(as % of merchandise exports) in Yemen, Rep. in 1999 to that in 2006?
Ensure brevity in your answer.  1.02. What is the ratio of the Exports(as % of merchandise exports) in Faeroe Islands in 1999 to that in 2007?
Give a very brief answer. 0. What is the ratio of the Exports(as % of merchandise exports) of Malaysia in 1999 to that in 2007?
Your response must be concise. 0.47. What is the ratio of the Exports(as % of merchandise exports) of Trinidad and Tobago in 1999 to that in 2007?
Your answer should be very brief. 0.82. What is the ratio of the Exports(as % of merchandise exports) in Yemen, Rep. in 1999 to that in 2007?
Your answer should be very brief. 1.05. What is the ratio of the Exports(as % of merchandise exports) of Faeroe Islands in 2000 to that in 2006?
Offer a terse response. 0. What is the ratio of the Exports(as % of merchandise exports) of Malaysia in 2000 to that in 2006?
Your answer should be very brief. 0.7. What is the ratio of the Exports(as % of merchandise exports) of Trinidad and Tobago in 2000 to that in 2006?
Give a very brief answer. 0.85. What is the ratio of the Exports(as % of merchandise exports) of Yemen, Rep. in 2000 to that in 2006?
Keep it short and to the point. 1.03. What is the ratio of the Exports(as % of merchandise exports) in Faeroe Islands in 2000 to that in 2007?
Your response must be concise. 0. What is the ratio of the Exports(as % of merchandise exports) in Malaysia in 2000 to that in 2007?
Give a very brief answer. 0.67. What is the ratio of the Exports(as % of merchandise exports) in Trinidad and Tobago in 2000 to that in 2007?
Your response must be concise. 0.99. What is the ratio of the Exports(as % of merchandise exports) of Yemen, Rep. in 2000 to that in 2007?
Your answer should be compact. 1.06. What is the ratio of the Exports(as % of merchandise exports) in Faeroe Islands in 2006 to that in 2007?
Make the answer very short. 1.13. What is the ratio of the Exports(as % of merchandise exports) of Malaysia in 2006 to that in 2007?
Offer a terse response. 0.96. What is the ratio of the Exports(as % of merchandise exports) in Trinidad and Tobago in 2006 to that in 2007?
Provide a short and direct response. 1.16. What is the ratio of the Exports(as % of merchandise exports) in Yemen, Rep. in 2006 to that in 2007?
Offer a very short reply. 1.04. What is the difference between the highest and the second highest Exports(as % of merchandise exports) of Faeroe Islands?
Ensure brevity in your answer.  0.22. What is the difference between the highest and the second highest Exports(as % of merchandise exports) of Malaysia?
Keep it short and to the point. 0.63. What is the difference between the highest and the second highest Exports(as % of merchandise exports) of Trinidad and Tobago?
Provide a succinct answer. 10.38. What is the difference between the highest and the second highest Exports(as % of merchandise exports) in Yemen, Rep.?
Your response must be concise. 0.93. What is the difference between the highest and the lowest Exports(as % of merchandise exports) of Faeroe Islands?
Your answer should be very brief. 1.95. What is the difference between the highest and the lowest Exports(as % of merchandise exports) in Malaysia?
Make the answer very short. 8.24. What is the difference between the highest and the lowest Exports(as % of merchandise exports) of Trinidad and Tobago?
Make the answer very short. 31.91. What is the difference between the highest and the lowest Exports(as % of merchandise exports) of Yemen, Rep.?
Make the answer very short. 5.67. 